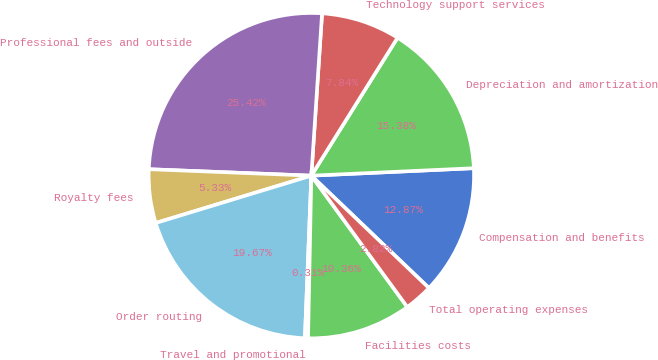Convert chart. <chart><loc_0><loc_0><loc_500><loc_500><pie_chart><fcel>Compensation and benefits<fcel>Depreciation and amortization<fcel>Technology support services<fcel>Professional fees and outside<fcel>Royalty fees<fcel>Order routing<fcel>Travel and promotional<fcel>Facilities costs<fcel>Total operating expenses<nl><fcel>12.87%<fcel>15.38%<fcel>7.84%<fcel>25.42%<fcel>5.33%<fcel>19.67%<fcel>0.31%<fcel>10.36%<fcel>2.82%<nl></chart> 